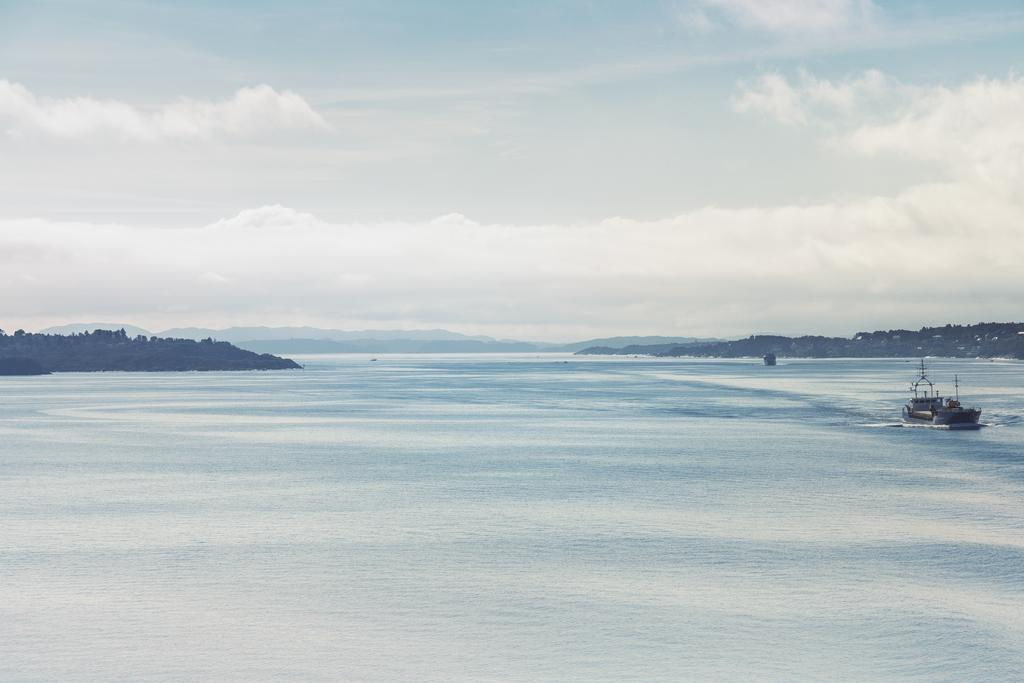What is the main subject of the image? There is a boat in the image. What is the boat doing in the image? The boat is sailing on the water. What can be seen in the background of the image? There are mountains and the sky visible in the background of the image. What type of knee is visible in the image? There is no knee present in the image; it features a boat sailing on the water with mountains and the sky in the background. 